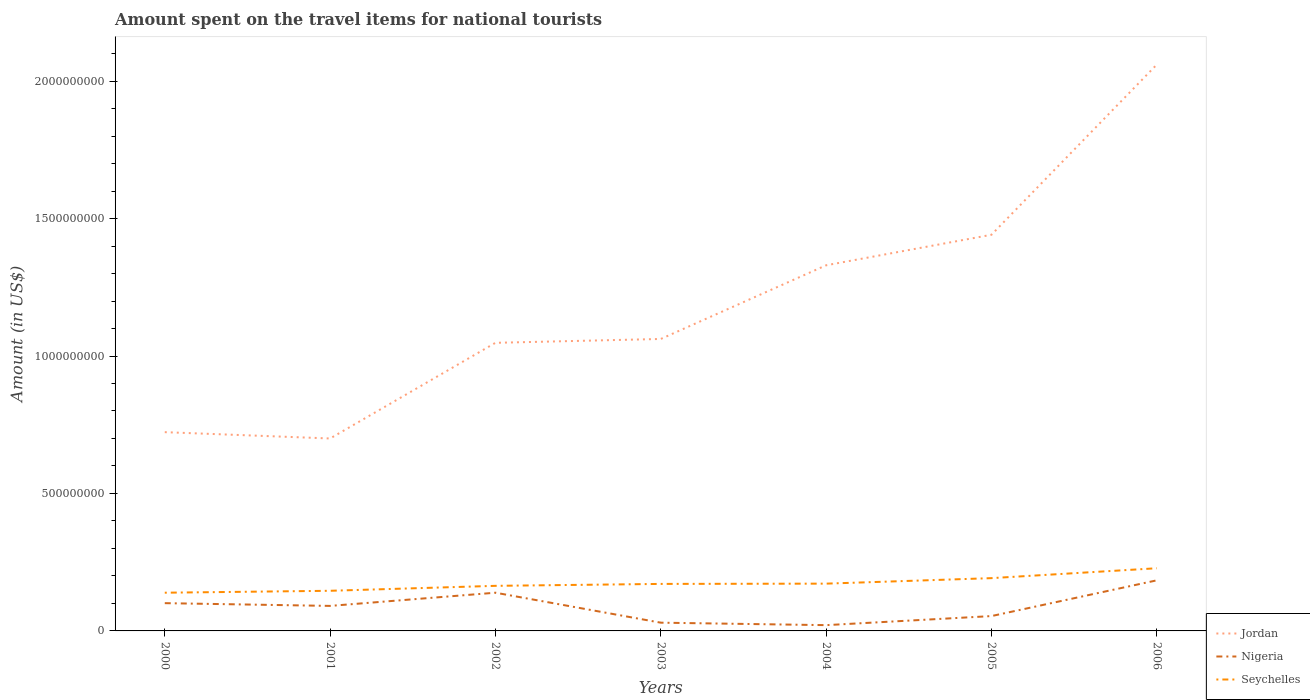Does the line corresponding to Nigeria intersect with the line corresponding to Jordan?
Provide a succinct answer. No. Across all years, what is the maximum amount spent on the travel items for national tourists in Nigeria?
Provide a succinct answer. 2.10e+07. In which year was the amount spent on the travel items for national tourists in Jordan maximum?
Provide a succinct answer. 2001. What is the total amount spent on the travel items for national tourists in Seychelles in the graph?
Keep it short and to the point. -6.40e+07. What is the difference between the highest and the second highest amount spent on the travel items for national tourists in Jordan?
Your answer should be very brief. 1.36e+09. Is the amount spent on the travel items for national tourists in Nigeria strictly greater than the amount spent on the travel items for national tourists in Jordan over the years?
Ensure brevity in your answer.  Yes. How many lines are there?
Provide a succinct answer. 3. Does the graph contain any zero values?
Keep it short and to the point. No. Where does the legend appear in the graph?
Offer a very short reply. Bottom right. How many legend labels are there?
Your answer should be compact. 3. How are the legend labels stacked?
Your response must be concise. Vertical. What is the title of the graph?
Provide a short and direct response. Amount spent on the travel items for national tourists. Does "Colombia" appear as one of the legend labels in the graph?
Your answer should be compact. No. What is the label or title of the X-axis?
Your response must be concise. Years. What is the Amount (in US$) in Jordan in 2000?
Provide a succinct answer. 7.23e+08. What is the Amount (in US$) in Nigeria in 2000?
Provide a succinct answer. 1.01e+08. What is the Amount (in US$) of Seychelles in 2000?
Give a very brief answer. 1.39e+08. What is the Amount (in US$) in Jordan in 2001?
Ensure brevity in your answer.  7.00e+08. What is the Amount (in US$) in Nigeria in 2001?
Offer a very short reply. 9.10e+07. What is the Amount (in US$) of Seychelles in 2001?
Offer a terse response. 1.46e+08. What is the Amount (in US$) of Jordan in 2002?
Offer a terse response. 1.05e+09. What is the Amount (in US$) of Nigeria in 2002?
Your response must be concise. 1.39e+08. What is the Amount (in US$) in Seychelles in 2002?
Offer a very short reply. 1.64e+08. What is the Amount (in US$) in Jordan in 2003?
Offer a very short reply. 1.06e+09. What is the Amount (in US$) of Nigeria in 2003?
Provide a short and direct response. 3.00e+07. What is the Amount (in US$) in Seychelles in 2003?
Offer a very short reply. 1.71e+08. What is the Amount (in US$) of Jordan in 2004?
Provide a short and direct response. 1.33e+09. What is the Amount (in US$) in Nigeria in 2004?
Ensure brevity in your answer.  2.10e+07. What is the Amount (in US$) in Seychelles in 2004?
Make the answer very short. 1.72e+08. What is the Amount (in US$) of Jordan in 2005?
Your answer should be very brief. 1.44e+09. What is the Amount (in US$) in Nigeria in 2005?
Your answer should be very brief. 5.40e+07. What is the Amount (in US$) in Seychelles in 2005?
Provide a succinct answer. 1.92e+08. What is the Amount (in US$) in Jordan in 2006?
Provide a short and direct response. 2.06e+09. What is the Amount (in US$) of Nigeria in 2006?
Your answer should be very brief. 1.84e+08. What is the Amount (in US$) in Seychelles in 2006?
Provide a short and direct response. 2.28e+08. Across all years, what is the maximum Amount (in US$) in Jordan?
Give a very brief answer. 2.06e+09. Across all years, what is the maximum Amount (in US$) in Nigeria?
Your response must be concise. 1.84e+08. Across all years, what is the maximum Amount (in US$) in Seychelles?
Provide a succinct answer. 2.28e+08. Across all years, what is the minimum Amount (in US$) in Jordan?
Your answer should be very brief. 7.00e+08. Across all years, what is the minimum Amount (in US$) of Nigeria?
Your answer should be compact. 2.10e+07. Across all years, what is the minimum Amount (in US$) of Seychelles?
Your answer should be very brief. 1.39e+08. What is the total Amount (in US$) of Jordan in the graph?
Keep it short and to the point. 8.36e+09. What is the total Amount (in US$) of Nigeria in the graph?
Offer a terse response. 6.20e+08. What is the total Amount (in US$) in Seychelles in the graph?
Your answer should be compact. 1.21e+09. What is the difference between the Amount (in US$) of Jordan in 2000 and that in 2001?
Keep it short and to the point. 2.30e+07. What is the difference between the Amount (in US$) of Seychelles in 2000 and that in 2001?
Give a very brief answer. -7.00e+06. What is the difference between the Amount (in US$) in Jordan in 2000 and that in 2002?
Offer a terse response. -3.25e+08. What is the difference between the Amount (in US$) in Nigeria in 2000 and that in 2002?
Ensure brevity in your answer.  -3.80e+07. What is the difference between the Amount (in US$) of Seychelles in 2000 and that in 2002?
Ensure brevity in your answer.  -2.50e+07. What is the difference between the Amount (in US$) of Jordan in 2000 and that in 2003?
Your answer should be very brief. -3.39e+08. What is the difference between the Amount (in US$) in Nigeria in 2000 and that in 2003?
Your response must be concise. 7.10e+07. What is the difference between the Amount (in US$) of Seychelles in 2000 and that in 2003?
Offer a very short reply. -3.20e+07. What is the difference between the Amount (in US$) in Jordan in 2000 and that in 2004?
Provide a succinct answer. -6.07e+08. What is the difference between the Amount (in US$) of Nigeria in 2000 and that in 2004?
Your answer should be compact. 8.00e+07. What is the difference between the Amount (in US$) of Seychelles in 2000 and that in 2004?
Your response must be concise. -3.30e+07. What is the difference between the Amount (in US$) of Jordan in 2000 and that in 2005?
Your answer should be very brief. -7.18e+08. What is the difference between the Amount (in US$) in Nigeria in 2000 and that in 2005?
Keep it short and to the point. 4.70e+07. What is the difference between the Amount (in US$) in Seychelles in 2000 and that in 2005?
Make the answer very short. -5.30e+07. What is the difference between the Amount (in US$) of Jordan in 2000 and that in 2006?
Keep it short and to the point. -1.34e+09. What is the difference between the Amount (in US$) of Nigeria in 2000 and that in 2006?
Keep it short and to the point. -8.30e+07. What is the difference between the Amount (in US$) in Seychelles in 2000 and that in 2006?
Give a very brief answer. -8.90e+07. What is the difference between the Amount (in US$) in Jordan in 2001 and that in 2002?
Give a very brief answer. -3.48e+08. What is the difference between the Amount (in US$) of Nigeria in 2001 and that in 2002?
Your answer should be very brief. -4.80e+07. What is the difference between the Amount (in US$) in Seychelles in 2001 and that in 2002?
Your response must be concise. -1.80e+07. What is the difference between the Amount (in US$) of Jordan in 2001 and that in 2003?
Offer a very short reply. -3.62e+08. What is the difference between the Amount (in US$) of Nigeria in 2001 and that in 2003?
Offer a very short reply. 6.10e+07. What is the difference between the Amount (in US$) of Seychelles in 2001 and that in 2003?
Offer a terse response. -2.50e+07. What is the difference between the Amount (in US$) of Jordan in 2001 and that in 2004?
Keep it short and to the point. -6.30e+08. What is the difference between the Amount (in US$) of Nigeria in 2001 and that in 2004?
Offer a terse response. 7.00e+07. What is the difference between the Amount (in US$) of Seychelles in 2001 and that in 2004?
Your answer should be very brief. -2.60e+07. What is the difference between the Amount (in US$) of Jordan in 2001 and that in 2005?
Your response must be concise. -7.41e+08. What is the difference between the Amount (in US$) of Nigeria in 2001 and that in 2005?
Keep it short and to the point. 3.70e+07. What is the difference between the Amount (in US$) of Seychelles in 2001 and that in 2005?
Offer a very short reply. -4.60e+07. What is the difference between the Amount (in US$) of Jordan in 2001 and that in 2006?
Offer a very short reply. -1.36e+09. What is the difference between the Amount (in US$) in Nigeria in 2001 and that in 2006?
Your answer should be very brief. -9.30e+07. What is the difference between the Amount (in US$) in Seychelles in 2001 and that in 2006?
Ensure brevity in your answer.  -8.20e+07. What is the difference between the Amount (in US$) in Jordan in 2002 and that in 2003?
Give a very brief answer. -1.40e+07. What is the difference between the Amount (in US$) in Nigeria in 2002 and that in 2003?
Offer a terse response. 1.09e+08. What is the difference between the Amount (in US$) of Seychelles in 2002 and that in 2003?
Keep it short and to the point. -7.00e+06. What is the difference between the Amount (in US$) of Jordan in 2002 and that in 2004?
Provide a short and direct response. -2.82e+08. What is the difference between the Amount (in US$) of Nigeria in 2002 and that in 2004?
Your answer should be very brief. 1.18e+08. What is the difference between the Amount (in US$) in Seychelles in 2002 and that in 2004?
Ensure brevity in your answer.  -8.00e+06. What is the difference between the Amount (in US$) of Jordan in 2002 and that in 2005?
Offer a terse response. -3.93e+08. What is the difference between the Amount (in US$) in Nigeria in 2002 and that in 2005?
Offer a terse response. 8.50e+07. What is the difference between the Amount (in US$) of Seychelles in 2002 and that in 2005?
Make the answer very short. -2.80e+07. What is the difference between the Amount (in US$) in Jordan in 2002 and that in 2006?
Your response must be concise. -1.01e+09. What is the difference between the Amount (in US$) of Nigeria in 2002 and that in 2006?
Provide a short and direct response. -4.50e+07. What is the difference between the Amount (in US$) in Seychelles in 2002 and that in 2006?
Your answer should be compact. -6.40e+07. What is the difference between the Amount (in US$) of Jordan in 2003 and that in 2004?
Offer a terse response. -2.68e+08. What is the difference between the Amount (in US$) in Nigeria in 2003 and that in 2004?
Offer a terse response. 9.00e+06. What is the difference between the Amount (in US$) in Jordan in 2003 and that in 2005?
Your answer should be very brief. -3.79e+08. What is the difference between the Amount (in US$) in Nigeria in 2003 and that in 2005?
Provide a short and direct response. -2.40e+07. What is the difference between the Amount (in US$) of Seychelles in 2003 and that in 2005?
Your response must be concise. -2.10e+07. What is the difference between the Amount (in US$) in Jordan in 2003 and that in 2006?
Ensure brevity in your answer.  -9.98e+08. What is the difference between the Amount (in US$) of Nigeria in 2003 and that in 2006?
Your answer should be very brief. -1.54e+08. What is the difference between the Amount (in US$) of Seychelles in 2003 and that in 2006?
Your answer should be compact. -5.70e+07. What is the difference between the Amount (in US$) of Jordan in 2004 and that in 2005?
Provide a short and direct response. -1.11e+08. What is the difference between the Amount (in US$) in Nigeria in 2004 and that in 2005?
Your answer should be compact. -3.30e+07. What is the difference between the Amount (in US$) of Seychelles in 2004 and that in 2005?
Keep it short and to the point. -2.00e+07. What is the difference between the Amount (in US$) in Jordan in 2004 and that in 2006?
Give a very brief answer. -7.30e+08. What is the difference between the Amount (in US$) of Nigeria in 2004 and that in 2006?
Make the answer very short. -1.63e+08. What is the difference between the Amount (in US$) in Seychelles in 2004 and that in 2006?
Make the answer very short. -5.60e+07. What is the difference between the Amount (in US$) of Jordan in 2005 and that in 2006?
Offer a very short reply. -6.19e+08. What is the difference between the Amount (in US$) in Nigeria in 2005 and that in 2006?
Keep it short and to the point. -1.30e+08. What is the difference between the Amount (in US$) in Seychelles in 2005 and that in 2006?
Provide a succinct answer. -3.60e+07. What is the difference between the Amount (in US$) in Jordan in 2000 and the Amount (in US$) in Nigeria in 2001?
Offer a very short reply. 6.32e+08. What is the difference between the Amount (in US$) in Jordan in 2000 and the Amount (in US$) in Seychelles in 2001?
Offer a very short reply. 5.77e+08. What is the difference between the Amount (in US$) in Nigeria in 2000 and the Amount (in US$) in Seychelles in 2001?
Provide a short and direct response. -4.50e+07. What is the difference between the Amount (in US$) in Jordan in 2000 and the Amount (in US$) in Nigeria in 2002?
Make the answer very short. 5.84e+08. What is the difference between the Amount (in US$) in Jordan in 2000 and the Amount (in US$) in Seychelles in 2002?
Your answer should be very brief. 5.59e+08. What is the difference between the Amount (in US$) of Nigeria in 2000 and the Amount (in US$) of Seychelles in 2002?
Give a very brief answer. -6.30e+07. What is the difference between the Amount (in US$) in Jordan in 2000 and the Amount (in US$) in Nigeria in 2003?
Offer a very short reply. 6.93e+08. What is the difference between the Amount (in US$) of Jordan in 2000 and the Amount (in US$) of Seychelles in 2003?
Your answer should be compact. 5.52e+08. What is the difference between the Amount (in US$) in Nigeria in 2000 and the Amount (in US$) in Seychelles in 2003?
Your answer should be very brief. -7.00e+07. What is the difference between the Amount (in US$) in Jordan in 2000 and the Amount (in US$) in Nigeria in 2004?
Provide a succinct answer. 7.02e+08. What is the difference between the Amount (in US$) of Jordan in 2000 and the Amount (in US$) of Seychelles in 2004?
Offer a very short reply. 5.51e+08. What is the difference between the Amount (in US$) of Nigeria in 2000 and the Amount (in US$) of Seychelles in 2004?
Give a very brief answer. -7.10e+07. What is the difference between the Amount (in US$) of Jordan in 2000 and the Amount (in US$) of Nigeria in 2005?
Your answer should be compact. 6.69e+08. What is the difference between the Amount (in US$) in Jordan in 2000 and the Amount (in US$) in Seychelles in 2005?
Make the answer very short. 5.31e+08. What is the difference between the Amount (in US$) in Nigeria in 2000 and the Amount (in US$) in Seychelles in 2005?
Give a very brief answer. -9.10e+07. What is the difference between the Amount (in US$) of Jordan in 2000 and the Amount (in US$) of Nigeria in 2006?
Offer a very short reply. 5.39e+08. What is the difference between the Amount (in US$) in Jordan in 2000 and the Amount (in US$) in Seychelles in 2006?
Keep it short and to the point. 4.95e+08. What is the difference between the Amount (in US$) of Nigeria in 2000 and the Amount (in US$) of Seychelles in 2006?
Your response must be concise. -1.27e+08. What is the difference between the Amount (in US$) in Jordan in 2001 and the Amount (in US$) in Nigeria in 2002?
Provide a short and direct response. 5.61e+08. What is the difference between the Amount (in US$) of Jordan in 2001 and the Amount (in US$) of Seychelles in 2002?
Your answer should be very brief. 5.36e+08. What is the difference between the Amount (in US$) of Nigeria in 2001 and the Amount (in US$) of Seychelles in 2002?
Ensure brevity in your answer.  -7.30e+07. What is the difference between the Amount (in US$) of Jordan in 2001 and the Amount (in US$) of Nigeria in 2003?
Offer a very short reply. 6.70e+08. What is the difference between the Amount (in US$) of Jordan in 2001 and the Amount (in US$) of Seychelles in 2003?
Offer a very short reply. 5.29e+08. What is the difference between the Amount (in US$) in Nigeria in 2001 and the Amount (in US$) in Seychelles in 2003?
Provide a succinct answer. -8.00e+07. What is the difference between the Amount (in US$) of Jordan in 2001 and the Amount (in US$) of Nigeria in 2004?
Give a very brief answer. 6.79e+08. What is the difference between the Amount (in US$) in Jordan in 2001 and the Amount (in US$) in Seychelles in 2004?
Your answer should be very brief. 5.28e+08. What is the difference between the Amount (in US$) of Nigeria in 2001 and the Amount (in US$) of Seychelles in 2004?
Provide a succinct answer. -8.10e+07. What is the difference between the Amount (in US$) of Jordan in 2001 and the Amount (in US$) of Nigeria in 2005?
Offer a terse response. 6.46e+08. What is the difference between the Amount (in US$) of Jordan in 2001 and the Amount (in US$) of Seychelles in 2005?
Your answer should be compact. 5.08e+08. What is the difference between the Amount (in US$) of Nigeria in 2001 and the Amount (in US$) of Seychelles in 2005?
Give a very brief answer. -1.01e+08. What is the difference between the Amount (in US$) of Jordan in 2001 and the Amount (in US$) of Nigeria in 2006?
Make the answer very short. 5.16e+08. What is the difference between the Amount (in US$) of Jordan in 2001 and the Amount (in US$) of Seychelles in 2006?
Offer a very short reply. 4.72e+08. What is the difference between the Amount (in US$) of Nigeria in 2001 and the Amount (in US$) of Seychelles in 2006?
Offer a terse response. -1.37e+08. What is the difference between the Amount (in US$) of Jordan in 2002 and the Amount (in US$) of Nigeria in 2003?
Your response must be concise. 1.02e+09. What is the difference between the Amount (in US$) of Jordan in 2002 and the Amount (in US$) of Seychelles in 2003?
Keep it short and to the point. 8.77e+08. What is the difference between the Amount (in US$) in Nigeria in 2002 and the Amount (in US$) in Seychelles in 2003?
Provide a succinct answer. -3.20e+07. What is the difference between the Amount (in US$) of Jordan in 2002 and the Amount (in US$) of Nigeria in 2004?
Your answer should be compact. 1.03e+09. What is the difference between the Amount (in US$) in Jordan in 2002 and the Amount (in US$) in Seychelles in 2004?
Offer a very short reply. 8.76e+08. What is the difference between the Amount (in US$) of Nigeria in 2002 and the Amount (in US$) of Seychelles in 2004?
Provide a succinct answer. -3.30e+07. What is the difference between the Amount (in US$) of Jordan in 2002 and the Amount (in US$) of Nigeria in 2005?
Provide a succinct answer. 9.94e+08. What is the difference between the Amount (in US$) of Jordan in 2002 and the Amount (in US$) of Seychelles in 2005?
Your answer should be very brief. 8.56e+08. What is the difference between the Amount (in US$) of Nigeria in 2002 and the Amount (in US$) of Seychelles in 2005?
Ensure brevity in your answer.  -5.30e+07. What is the difference between the Amount (in US$) of Jordan in 2002 and the Amount (in US$) of Nigeria in 2006?
Your answer should be compact. 8.64e+08. What is the difference between the Amount (in US$) in Jordan in 2002 and the Amount (in US$) in Seychelles in 2006?
Make the answer very short. 8.20e+08. What is the difference between the Amount (in US$) of Nigeria in 2002 and the Amount (in US$) of Seychelles in 2006?
Provide a short and direct response. -8.90e+07. What is the difference between the Amount (in US$) in Jordan in 2003 and the Amount (in US$) in Nigeria in 2004?
Make the answer very short. 1.04e+09. What is the difference between the Amount (in US$) of Jordan in 2003 and the Amount (in US$) of Seychelles in 2004?
Provide a succinct answer. 8.90e+08. What is the difference between the Amount (in US$) of Nigeria in 2003 and the Amount (in US$) of Seychelles in 2004?
Provide a short and direct response. -1.42e+08. What is the difference between the Amount (in US$) in Jordan in 2003 and the Amount (in US$) in Nigeria in 2005?
Make the answer very short. 1.01e+09. What is the difference between the Amount (in US$) in Jordan in 2003 and the Amount (in US$) in Seychelles in 2005?
Provide a succinct answer. 8.70e+08. What is the difference between the Amount (in US$) in Nigeria in 2003 and the Amount (in US$) in Seychelles in 2005?
Provide a succinct answer. -1.62e+08. What is the difference between the Amount (in US$) in Jordan in 2003 and the Amount (in US$) in Nigeria in 2006?
Make the answer very short. 8.78e+08. What is the difference between the Amount (in US$) in Jordan in 2003 and the Amount (in US$) in Seychelles in 2006?
Your answer should be compact. 8.34e+08. What is the difference between the Amount (in US$) in Nigeria in 2003 and the Amount (in US$) in Seychelles in 2006?
Keep it short and to the point. -1.98e+08. What is the difference between the Amount (in US$) of Jordan in 2004 and the Amount (in US$) of Nigeria in 2005?
Offer a terse response. 1.28e+09. What is the difference between the Amount (in US$) in Jordan in 2004 and the Amount (in US$) in Seychelles in 2005?
Provide a short and direct response. 1.14e+09. What is the difference between the Amount (in US$) of Nigeria in 2004 and the Amount (in US$) of Seychelles in 2005?
Your response must be concise. -1.71e+08. What is the difference between the Amount (in US$) of Jordan in 2004 and the Amount (in US$) of Nigeria in 2006?
Make the answer very short. 1.15e+09. What is the difference between the Amount (in US$) in Jordan in 2004 and the Amount (in US$) in Seychelles in 2006?
Your answer should be very brief. 1.10e+09. What is the difference between the Amount (in US$) in Nigeria in 2004 and the Amount (in US$) in Seychelles in 2006?
Offer a very short reply. -2.07e+08. What is the difference between the Amount (in US$) of Jordan in 2005 and the Amount (in US$) of Nigeria in 2006?
Provide a succinct answer. 1.26e+09. What is the difference between the Amount (in US$) of Jordan in 2005 and the Amount (in US$) of Seychelles in 2006?
Make the answer very short. 1.21e+09. What is the difference between the Amount (in US$) of Nigeria in 2005 and the Amount (in US$) of Seychelles in 2006?
Provide a succinct answer. -1.74e+08. What is the average Amount (in US$) in Jordan per year?
Keep it short and to the point. 1.19e+09. What is the average Amount (in US$) in Nigeria per year?
Ensure brevity in your answer.  8.86e+07. What is the average Amount (in US$) of Seychelles per year?
Provide a succinct answer. 1.73e+08. In the year 2000, what is the difference between the Amount (in US$) of Jordan and Amount (in US$) of Nigeria?
Provide a succinct answer. 6.22e+08. In the year 2000, what is the difference between the Amount (in US$) of Jordan and Amount (in US$) of Seychelles?
Your response must be concise. 5.84e+08. In the year 2000, what is the difference between the Amount (in US$) of Nigeria and Amount (in US$) of Seychelles?
Offer a terse response. -3.80e+07. In the year 2001, what is the difference between the Amount (in US$) in Jordan and Amount (in US$) in Nigeria?
Your answer should be compact. 6.09e+08. In the year 2001, what is the difference between the Amount (in US$) of Jordan and Amount (in US$) of Seychelles?
Offer a terse response. 5.54e+08. In the year 2001, what is the difference between the Amount (in US$) in Nigeria and Amount (in US$) in Seychelles?
Give a very brief answer. -5.50e+07. In the year 2002, what is the difference between the Amount (in US$) in Jordan and Amount (in US$) in Nigeria?
Offer a very short reply. 9.09e+08. In the year 2002, what is the difference between the Amount (in US$) in Jordan and Amount (in US$) in Seychelles?
Give a very brief answer. 8.84e+08. In the year 2002, what is the difference between the Amount (in US$) in Nigeria and Amount (in US$) in Seychelles?
Give a very brief answer. -2.50e+07. In the year 2003, what is the difference between the Amount (in US$) of Jordan and Amount (in US$) of Nigeria?
Your response must be concise. 1.03e+09. In the year 2003, what is the difference between the Amount (in US$) in Jordan and Amount (in US$) in Seychelles?
Offer a terse response. 8.91e+08. In the year 2003, what is the difference between the Amount (in US$) in Nigeria and Amount (in US$) in Seychelles?
Ensure brevity in your answer.  -1.41e+08. In the year 2004, what is the difference between the Amount (in US$) of Jordan and Amount (in US$) of Nigeria?
Give a very brief answer. 1.31e+09. In the year 2004, what is the difference between the Amount (in US$) in Jordan and Amount (in US$) in Seychelles?
Your response must be concise. 1.16e+09. In the year 2004, what is the difference between the Amount (in US$) of Nigeria and Amount (in US$) of Seychelles?
Make the answer very short. -1.51e+08. In the year 2005, what is the difference between the Amount (in US$) in Jordan and Amount (in US$) in Nigeria?
Provide a short and direct response. 1.39e+09. In the year 2005, what is the difference between the Amount (in US$) of Jordan and Amount (in US$) of Seychelles?
Offer a very short reply. 1.25e+09. In the year 2005, what is the difference between the Amount (in US$) in Nigeria and Amount (in US$) in Seychelles?
Your response must be concise. -1.38e+08. In the year 2006, what is the difference between the Amount (in US$) in Jordan and Amount (in US$) in Nigeria?
Keep it short and to the point. 1.88e+09. In the year 2006, what is the difference between the Amount (in US$) in Jordan and Amount (in US$) in Seychelles?
Your response must be concise. 1.83e+09. In the year 2006, what is the difference between the Amount (in US$) of Nigeria and Amount (in US$) of Seychelles?
Keep it short and to the point. -4.40e+07. What is the ratio of the Amount (in US$) of Jordan in 2000 to that in 2001?
Ensure brevity in your answer.  1.03. What is the ratio of the Amount (in US$) of Nigeria in 2000 to that in 2001?
Your answer should be compact. 1.11. What is the ratio of the Amount (in US$) in Seychelles in 2000 to that in 2001?
Your answer should be compact. 0.95. What is the ratio of the Amount (in US$) in Jordan in 2000 to that in 2002?
Offer a terse response. 0.69. What is the ratio of the Amount (in US$) of Nigeria in 2000 to that in 2002?
Offer a terse response. 0.73. What is the ratio of the Amount (in US$) of Seychelles in 2000 to that in 2002?
Your answer should be very brief. 0.85. What is the ratio of the Amount (in US$) of Jordan in 2000 to that in 2003?
Your response must be concise. 0.68. What is the ratio of the Amount (in US$) of Nigeria in 2000 to that in 2003?
Your response must be concise. 3.37. What is the ratio of the Amount (in US$) of Seychelles in 2000 to that in 2003?
Provide a short and direct response. 0.81. What is the ratio of the Amount (in US$) in Jordan in 2000 to that in 2004?
Your answer should be very brief. 0.54. What is the ratio of the Amount (in US$) in Nigeria in 2000 to that in 2004?
Provide a short and direct response. 4.81. What is the ratio of the Amount (in US$) of Seychelles in 2000 to that in 2004?
Offer a very short reply. 0.81. What is the ratio of the Amount (in US$) of Jordan in 2000 to that in 2005?
Make the answer very short. 0.5. What is the ratio of the Amount (in US$) in Nigeria in 2000 to that in 2005?
Make the answer very short. 1.87. What is the ratio of the Amount (in US$) in Seychelles in 2000 to that in 2005?
Your answer should be compact. 0.72. What is the ratio of the Amount (in US$) in Jordan in 2000 to that in 2006?
Your answer should be compact. 0.35. What is the ratio of the Amount (in US$) of Nigeria in 2000 to that in 2006?
Keep it short and to the point. 0.55. What is the ratio of the Amount (in US$) of Seychelles in 2000 to that in 2006?
Give a very brief answer. 0.61. What is the ratio of the Amount (in US$) of Jordan in 2001 to that in 2002?
Your response must be concise. 0.67. What is the ratio of the Amount (in US$) in Nigeria in 2001 to that in 2002?
Give a very brief answer. 0.65. What is the ratio of the Amount (in US$) in Seychelles in 2001 to that in 2002?
Make the answer very short. 0.89. What is the ratio of the Amount (in US$) of Jordan in 2001 to that in 2003?
Give a very brief answer. 0.66. What is the ratio of the Amount (in US$) of Nigeria in 2001 to that in 2003?
Your answer should be very brief. 3.03. What is the ratio of the Amount (in US$) of Seychelles in 2001 to that in 2003?
Provide a short and direct response. 0.85. What is the ratio of the Amount (in US$) in Jordan in 2001 to that in 2004?
Provide a short and direct response. 0.53. What is the ratio of the Amount (in US$) in Nigeria in 2001 to that in 2004?
Offer a very short reply. 4.33. What is the ratio of the Amount (in US$) in Seychelles in 2001 to that in 2004?
Give a very brief answer. 0.85. What is the ratio of the Amount (in US$) in Jordan in 2001 to that in 2005?
Provide a short and direct response. 0.49. What is the ratio of the Amount (in US$) in Nigeria in 2001 to that in 2005?
Give a very brief answer. 1.69. What is the ratio of the Amount (in US$) in Seychelles in 2001 to that in 2005?
Offer a very short reply. 0.76. What is the ratio of the Amount (in US$) in Jordan in 2001 to that in 2006?
Make the answer very short. 0.34. What is the ratio of the Amount (in US$) of Nigeria in 2001 to that in 2006?
Give a very brief answer. 0.49. What is the ratio of the Amount (in US$) in Seychelles in 2001 to that in 2006?
Your response must be concise. 0.64. What is the ratio of the Amount (in US$) in Jordan in 2002 to that in 2003?
Your answer should be compact. 0.99. What is the ratio of the Amount (in US$) of Nigeria in 2002 to that in 2003?
Offer a very short reply. 4.63. What is the ratio of the Amount (in US$) of Seychelles in 2002 to that in 2003?
Your answer should be compact. 0.96. What is the ratio of the Amount (in US$) of Jordan in 2002 to that in 2004?
Give a very brief answer. 0.79. What is the ratio of the Amount (in US$) in Nigeria in 2002 to that in 2004?
Provide a succinct answer. 6.62. What is the ratio of the Amount (in US$) of Seychelles in 2002 to that in 2004?
Your answer should be compact. 0.95. What is the ratio of the Amount (in US$) in Jordan in 2002 to that in 2005?
Your response must be concise. 0.73. What is the ratio of the Amount (in US$) in Nigeria in 2002 to that in 2005?
Provide a short and direct response. 2.57. What is the ratio of the Amount (in US$) in Seychelles in 2002 to that in 2005?
Your answer should be compact. 0.85. What is the ratio of the Amount (in US$) of Jordan in 2002 to that in 2006?
Your answer should be very brief. 0.51. What is the ratio of the Amount (in US$) of Nigeria in 2002 to that in 2006?
Make the answer very short. 0.76. What is the ratio of the Amount (in US$) of Seychelles in 2002 to that in 2006?
Offer a terse response. 0.72. What is the ratio of the Amount (in US$) in Jordan in 2003 to that in 2004?
Provide a short and direct response. 0.8. What is the ratio of the Amount (in US$) in Nigeria in 2003 to that in 2004?
Provide a succinct answer. 1.43. What is the ratio of the Amount (in US$) of Jordan in 2003 to that in 2005?
Keep it short and to the point. 0.74. What is the ratio of the Amount (in US$) of Nigeria in 2003 to that in 2005?
Make the answer very short. 0.56. What is the ratio of the Amount (in US$) of Seychelles in 2003 to that in 2005?
Give a very brief answer. 0.89. What is the ratio of the Amount (in US$) of Jordan in 2003 to that in 2006?
Make the answer very short. 0.52. What is the ratio of the Amount (in US$) of Nigeria in 2003 to that in 2006?
Make the answer very short. 0.16. What is the ratio of the Amount (in US$) in Seychelles in 2003 to that in 2006?
Offer a very short reply. 0.75. What is the ratio of the Amount (in US$) of Jordan in 2004 to that in 2005?
Give a very brief answer. 0.92. What is the ratio of the Amount (in US$) of Nigeria in 2004 to that in 2005?
Offer a very short reply. 0.39. What is the ratio of the Amount (in US$) in Seychelles in 2004 to that in 2005?
Offer a very short reply. 0.9. What is the ratio of the Amount (in US$) in Jordan in 2004 to that in 2006?
Make the answer very short. 0.65. What is the ratio of the Amount (in US$) in Nigeria in 2004 to that in 2006?
Offer a terse response. 0.11. What is the ratio of the Amount (in US$) in Seychelles in 2004 to that in 2006?
Provide a succinct answer. 0.75. What is the ratio of the Amount (in US$) in Jordan in 2005 to that in 2006?
Make the answer very short. 0.7. What is the ratio of the Amount (in US$) in Nigeria in 2005 to that in 2006?
Offer a very short reply. 0.29. What is the ratio of the Amount (in US$) in Seychelles in 2005 to that in 2006?
Make the answer very short. 0.84. What is the difference between the highest and the second highest Amount (in US$) of Jordan?
Ensure brevity in your answer.  6.19e+08. What is the difference between the highest and the second highest Amount (in US$) of Nigeria?
Ensure brevity in your answer.  4.50e+07. What is the difference between the highest and the second highest Amount (in US$) in Seychelles?
Make the answer very short. 3.60e+07. What is the difference between the highest and the lowest Amount (in US$) in Jordan?
Keep it short and to the point. 1.36e+09. What is the difference between the highest and the lowest Amount (in US$) in Nigeria?
Give a very brief answer. 1.63e+08. What is the difference between the highest and the lowest Amount (in US$) of Seychelles?
Your response must be concise. 8.90e+07. 